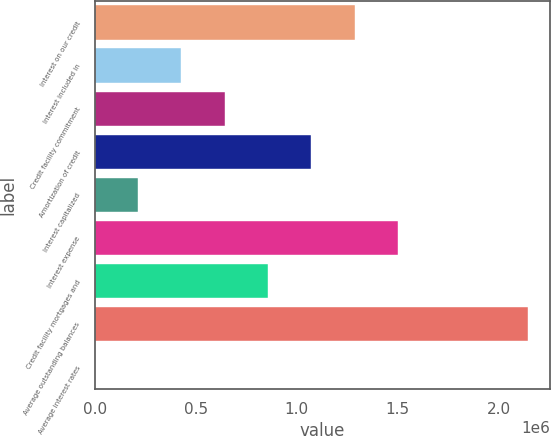<chart> <loc_0><loc_0><loc_500><loc_500><bar_chart><fcel>Interest on our credit<fcel>Interest included in<fcel>Credit facility commitment<fcel>Amortization of credit<fcel>Interest capitalized<fcel>Interest expense<fcel>Credit facility mortgages and<fcel>Average outstanding balances<fcel>Average interest rates<nl><fcel>1.28682e+06<fcel>428942<fcel>643411<fcel>1.07235e+06<fcel>214474<fcel>1.50128e+06<fcel>857879<fcel>2.14469e+06<fcel>5.5<nl></chart> 